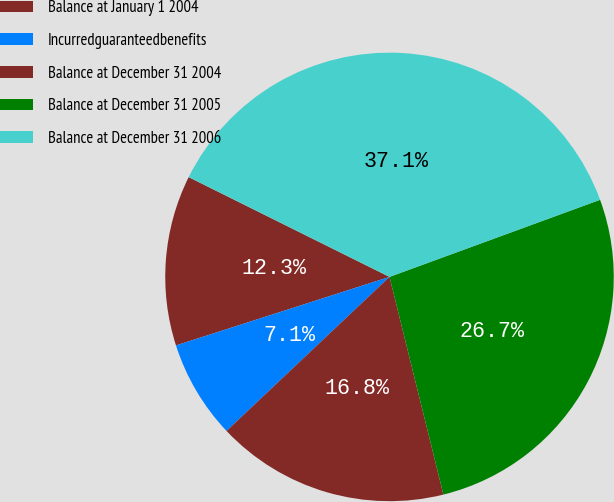Convert chart to OTSL. <chart><loc_0><loc_0><loc_500><loc_500><pie_chart><fcel>Balance at January 1 2004<fcel>Incurredguaranteedbenefits<fcel>Balance at December 31 2004<fcel>Balance at December 31 2005<fcel>Balance at December 31 2006<nl><fcel>12.28%<fcel>7.11%<fcel>16.81%<fcel>26.72%<fcel>37.07%<nl></chart> 